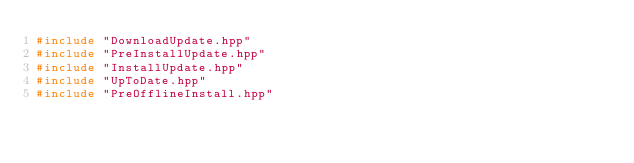Convert code to text. <code><loc_0><loc_0><loc_500><loc_500><_C++_>#include "DownloadUpdate.hpp"
#include "PreInstallUpdate.hpp"
#include "InstallUpdate.hpp"
#include "UpToDate.hpp"
#include "PreOfflineInstall.hpp"</code> 